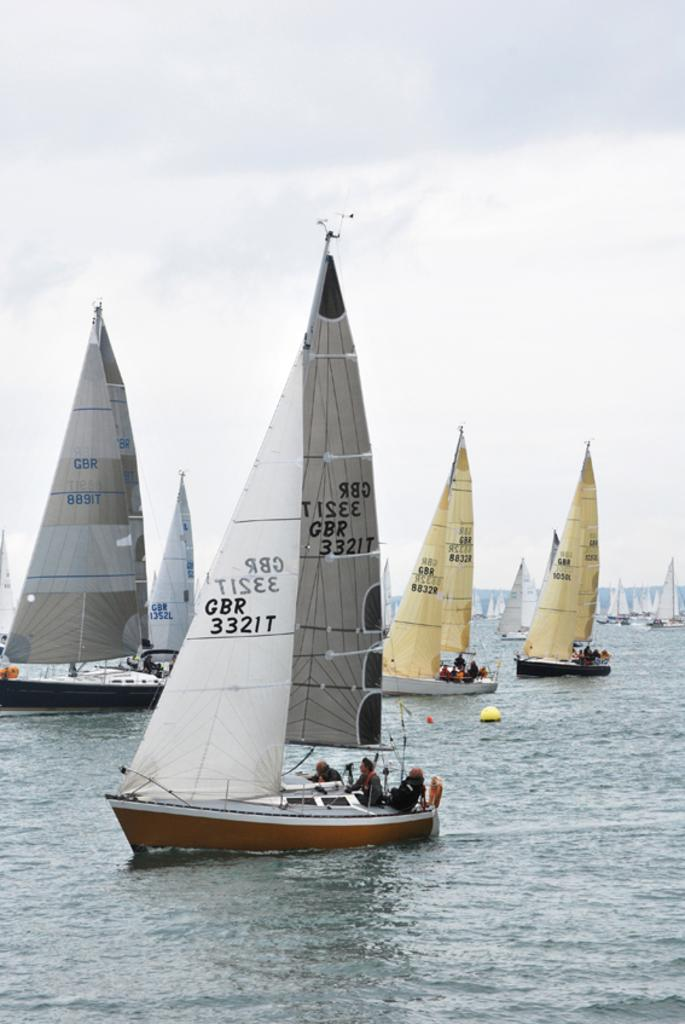<image>
Summarize the visual content of the image. Several sailboats are seen sailing in the water with the closest having the identifier GBR 3321T on the sail. 